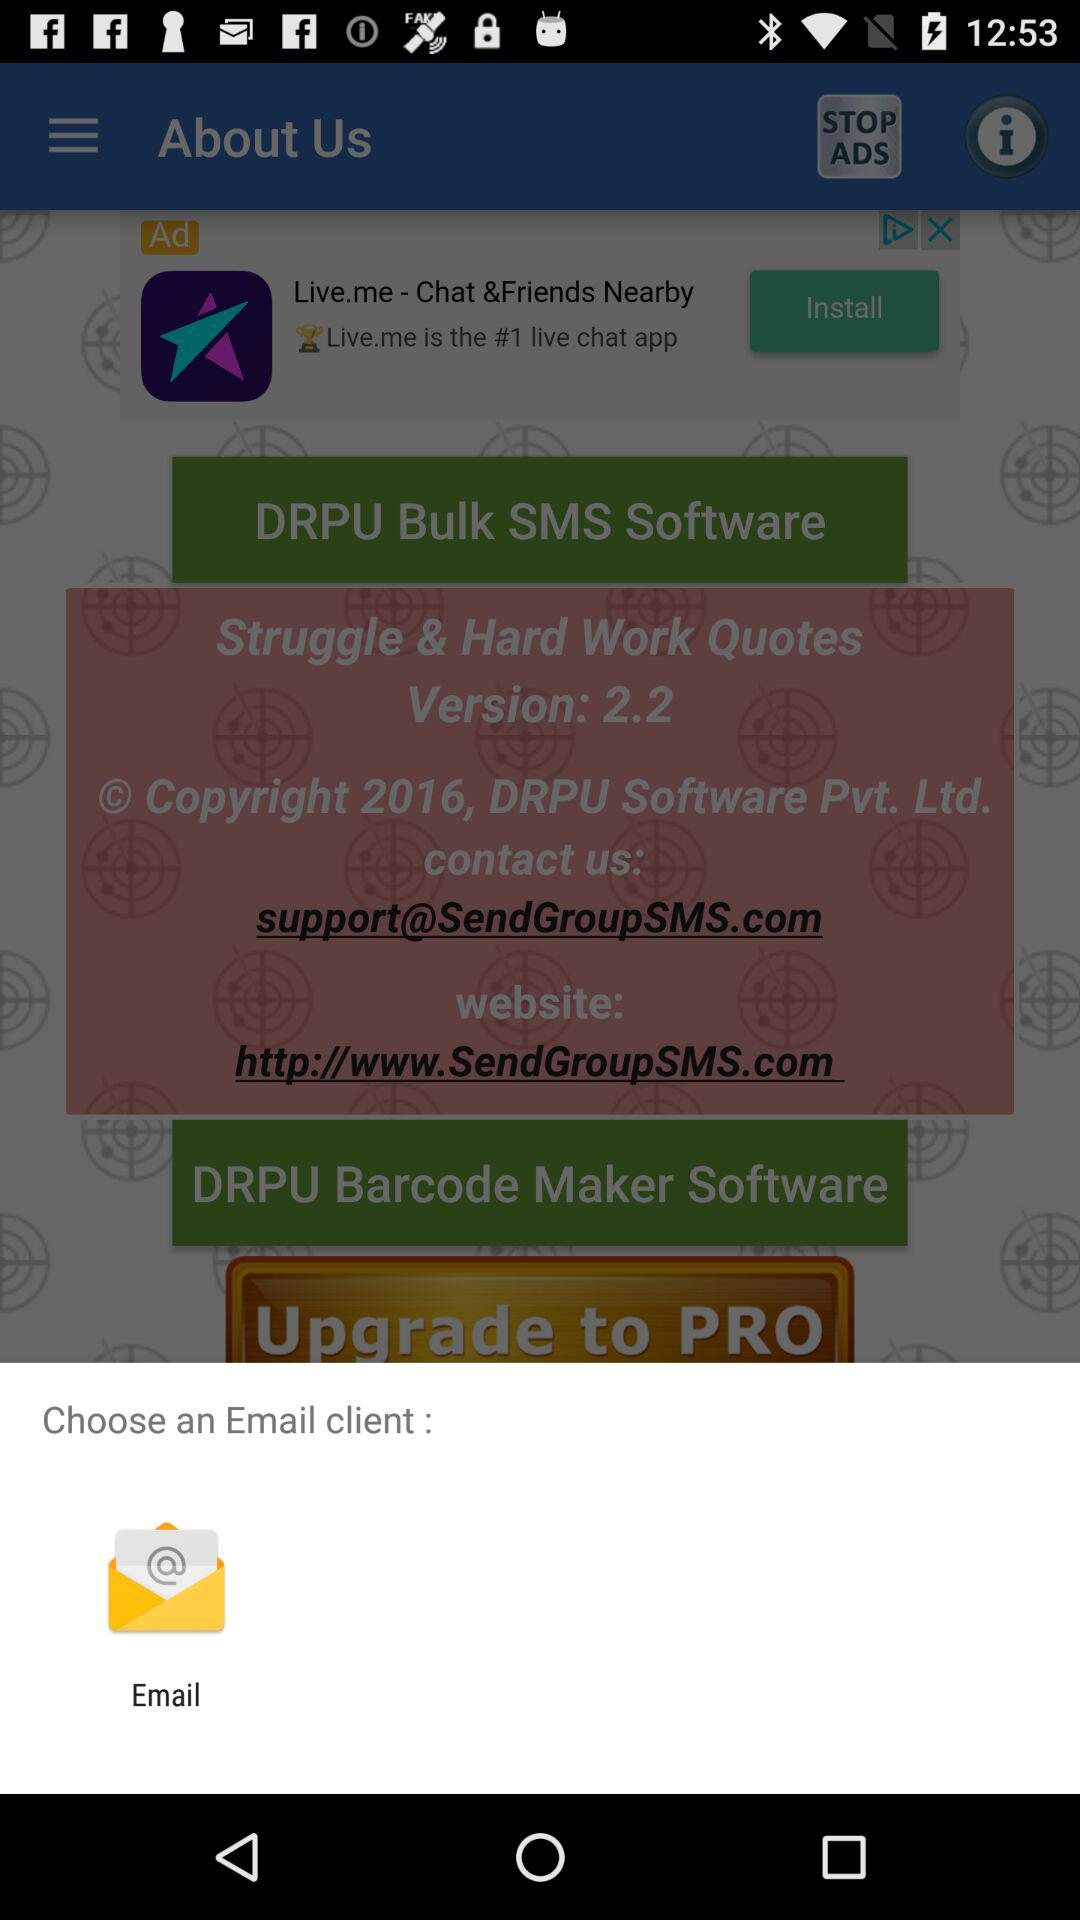What is the email address to contact "DRPU Software Pvt. Ltd."? The email address to contact is support@SendGroupSMS.com. 